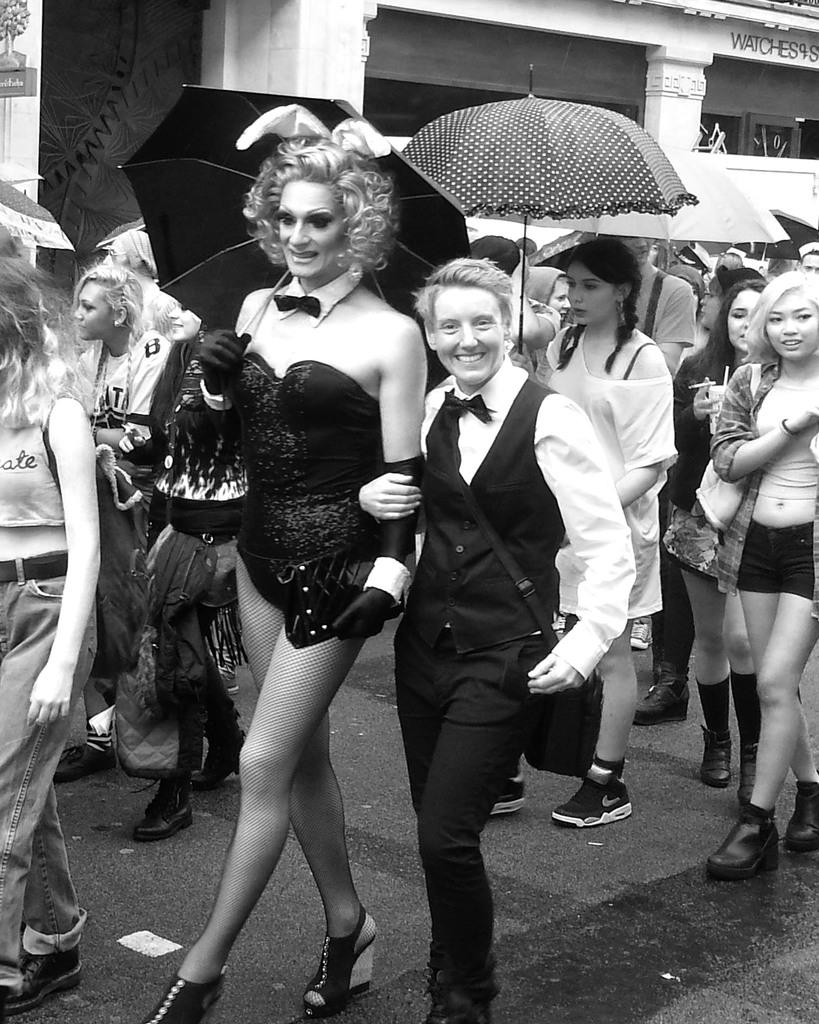What is the color scheme of the image? The image is black and white. How many people are in the image? There are multiple persons in the image. What are the people in the image doing? The persons are walking. Are any of the people carrying anything in the image? Yes, some of the persons are holding umbrellas. What can be seen in the background of the image? There is a building visible in the background. Is there a hill in the background of the image? There is no hill visible in the background of the image; only a building is present. 